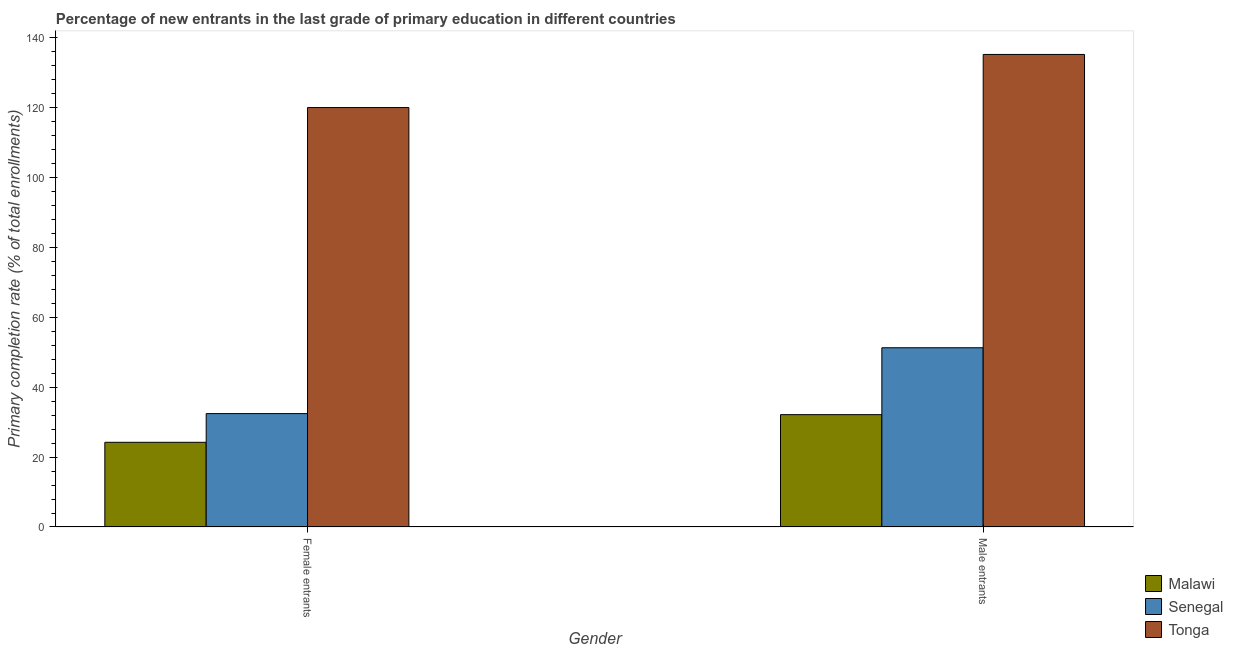How many different coloured bars are there?
Ensure brevity in your answer.  3. Are the number of bars per tick equal to the number of legend labels?
Keep it short and to the point. Yes. Are the number of bars on each tick of the X-axis equal?
Give a very brief answer. Yes. How many bars are there on the 1st tick from the right?
Your answer should be very brief. 3. What is the label of the 2nd group of bars from the left?
Offer a very short reply. Male entrants. What is the primary completion rate of male entrants in Senegal?
Keep it short and to the point. 51.26. Across all countries, what is the maximum primary completion rate of female entrants?
Ensure brevity in your answer.  119.95. Across all countries, what is the minimum primary completion rate of male entrants?
Give a very brief answer. 32.13. In which country was the primary completion rate of female entrants maximum?
Keep it short and to the point. Tonga. In which country was the primary completion rate of male entrants minimum?
Provide a succinct answer. Malawi. What is the total primary completion rate of male entrants in the graph?
Your answer should be compact. 218.52. What is the difference between the primary completion rate of female entrants in Tonga and that in Malawi?
Offer a terse response. 95.73. What is the difference between the primary completion rate of male entrants in Tonga and the primary completion rate of female entrants in Senegal?
Your answer should be very brief. 102.71. What is the average primary completion rate of male entrants per country?
Make the answer very short. 72.84. What is the difference between the primary completion rate of male entrants and primary completion rate of female entrants in Malawi?
Your answer should be very brief. 7.91. In how many countries, is the primary completion rate of male entrants greater than 20 %?
Give a very brief answer. 3. What is the ratio of the primary completion rate of female entrants in Senegal to that in Tonga?
Provide a short and direct response. 0.27. What does the 3rd bar from the left in Male entrants represents?
Offer a very short reply. Tonga. What does the 3rd bar from the right in Female entrants represents?
Offer a terse response. Malawi. Are all the bars in the graph horizontal?
Offer a very short reply. No. Are the values on the major ticks of Y-axis written in scientific E-notation?
Provide a succinct answer. No. Does the graph contain any zero values?
Offer a terse response. No. Does the graph contain grids?
Give a very brief answer. No. What is the title of the graph?
Your answer should be compact. Percentage of new entrants in the last grade of primary education in different countries. Does "Myanmar" appear as one of the legend labels in the graph?
Provide a succinct answer. No. What is the label or title of the Y-axis?
Make the answer very short. Primary completion rate (% of total enrollments). What is the Primary completion rate (% of total enrollments) in Malawi in Female entrants?
Your answer should be compact. 24.22. What is the Primary completion rate (% of total enrollments) in Senegal in Female entrants?
Ensure brevity in your answer.  32.43. What is the Primary completion rate (% of total enrollments) of Tonga in Female entrants?
Make the answer very short. 119.95. What is the Primary completion rate (% of total enrollments) in Malawi in Male entrants?
Offer a very short reply. 32.13. What is the Primary completion rate (% of total enrollments) in Senegal in Male entrants?
Keep it short and to the point. 51.26. What is the Primary completion rate (% of total enrollments) of Tonga in Male entrants?
Your answer should be very brief. 135.14. Across all Gender, what is the maximum Primary completion rate (% of total enrollments) in Malawi?
Give a very brief answer. 32.13. Across all Gender, what is the maximum Primary completion rate (% of total enrollments) of Senegal?
Provide a short and direct response. 51.26. Across all Gender, what is the maximum Primary completion rate (% of total enrollments) of Tonga?
Give a very brief answer. 135.14. Across all Gender, what is the minimum Primary completion rate (% of total enrollments) of Malawi?
Offer a terse response. 24.22. Across all Gender, what is the minimum Primary completion rate (% of total enrollments) in Senegal?
Provide a succinct answer. 32.43. Across all Gender, what is the minimum Primary completion rate (% of total enrollments) of Tonga?
Ensure brevity in your answer.  119.95. What is the total Primary completion rate (% of total enrollments) in Malawi in the graph?
Give a very brief answer. 56.35. What is the total Primary completion rate (% of total enrollments) in Senegal in the graph?
Make the answer very short. 83.69. What is the total Primary completion rate (% of total enrollments) of Tonga in the graph?
Keep it short and to the point. 255.08. What is the difference between the Primary completion rate (% of total enrollments) in Malawi in Female entrants and that in Male entrants?
Offer a very short reply. -7.91. What is the difference between the Primary completion rate (% of total enrollments) in Senegal in Female entrants and that in Male entrants?
Offer a very short reply. -18.83. What is the difference between the Primary completion rate (% of total enrollments) of Tonga in Female entrants and that in Male entrants?
Offer a very short reply. -15.19. What is the difference between the Primary completion rate (% of total enrollments) in Malawi in Female entrants and the Primary completion rate (% of total enrollments) in Senegal in Male entrants?
Make the answer very short. -27.04. What is the difference between the Primary completion rate (% of total enrollments) of Malawi in Female entrants and the Primary completion rate (% of total enrollments) of Tonga in Male entrants?
Your answer should be very brief. -110.92. What is the difference between the Primary completion rate (% of total enrollments) of Senegal in Female entrants and the Primary completion rate (% of total enrollments) of Tonga in Male entrants?
Keep it short and to the point. -102.71. What is the average Primary completion rate (% of total enrollments) of Malawi per Gender?
Keep it short and to the point. 28.17. What is the average Primary completion rate (% of total enrollments) of Senegal per Gender?
Offer a very short reply. 41.84. What is the average Primary completion rate (% of total enrollments) in Tonga per Gender?
Keep it short and to the point. 127.54. What is the difference between the Primary completion rate (% of total enrollments) of Malawi and Primary completion rate (% of total enrollments) of Senegal in Female entrants?
Provide a succinct answer. -8.21. What is the difference between the Primary completion rate (% of total enrollments) of Malawi and Primary completion rate (% of total enrollments) of Tonga in Female entrants?
Make the answer very short. -95.73. What is the difference between the Primary completion rate (% of total enrollments) of Senegal and Primary completion rate (% of total enrollments) of Tonga in Female entrants?
Your response must be concise. -87.52. What is the difference between the Primary completion rate (% of total enrollments) in Malawi and Primary completion rate (% of total enrollments) in Senegal in Male entrants?
Your answer should be compact. -19.13. What is the difference between the Primary completion rate (% of total enrollments) in Malawi and Primary completion rate (% of total enrollments) in Tonga in Male entrants?
Ensure brevity in your answer.  -103.01. What is the difference between the Primary completion rate (% of total enrollments) of Senegal and Primary completion rate (% of total enrollments) of Tonga in Male entrants?
Give a very brief answer. -83.88. What is the ratio of the Primary completion rate (% of total enrollments) in Malawi in Female entrants to that in Male entrants?
Offer a very short reply. 0.75. What is the ratio of the Primary completion rate (% of total enrollments) of Senegal in Female entrants to that in Male entrants?
Offer a terse response. 0.63. What is the ratio of the Primary completion rate (% of total enrollments) of Tonga in Female entrants to that in Male entrants?
Offer a very short reply. 0.89. What is the difference between the highest and the second highest Primary completion rate (% of total enrollments) in Malawi?
Provide a short and direct response. 7.91. What is the difference between the highest and the second highest Primary completion rate (% of total enrollments) of Senegal?
Make the answer very short. 18.83. What is the difference between the highest and the second highest Primary completion rate (% of total enrollments) in Tonga?
Your answer should be very brief. 15.19. What is the difference between the highest and the lowest Primary completion rate (% of total enrollments) of Malawi?
Offer a very short reply. 7.91. What is the difference between the highest and the lowest Primary completion rate (% of total enrollments) of Senegal?
Provide a short and direct response. 18.83. What is the difference between the highest and the lowest Primary completion rate (% of total enrollments) in Tonga?
Offer a very short reply. 15.19. 